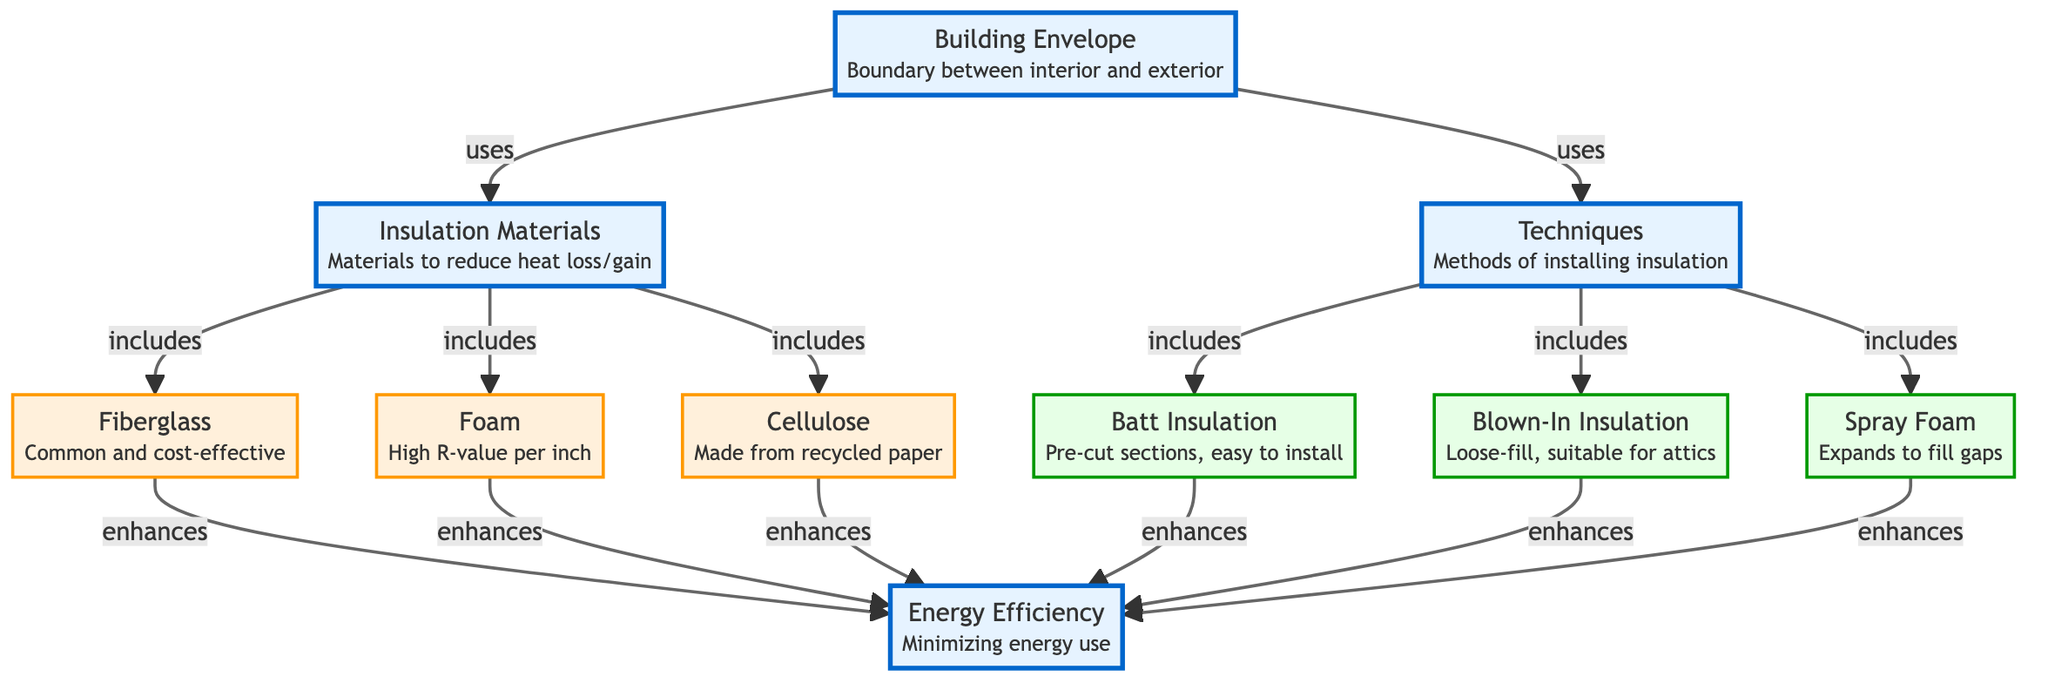What is the main purpose of the building envelope? The building envelope serves as the boundary between the interior and exterior of the building, helping to define the indoor climate.
Answer: Boundary between interior and exterior How many types of insulation materials are listed in the diagram? The diagram lists three types of insulation materials: Fiberglass, Foam, and Cellulose.
Answer: 3 What insulation technique is described as expanding to fill gaps? The technique described as expanding to fill gaps is Spray Foam, which is known for its ability to conform to spaces.
Answer: Spray Foam What enhances energy efficiency according to the diagram? Both insulation materials (Fiberglass, Foam, Cellulose) and installation techniques (Batts, Blown-In, Spray Foam) enhance energy efficiency, focusing on minimizing energy use in buildings.
Answer: Insulation materials and techniques Which insulation material is made from recycled paper? Cellulose is the insulation material made from recycled paper, emphasizing its environmentally friendly attributes.
Answer: Cellulose How are the insulation materials related to energy efficiency? The insulation materials (Fiberglass, Foam, Cellulose) enhance energy efficiency by reducing heat loss/gain, contributing to lower energy use in residential buildings.
Answer: Enhances energy efficiency What technique is characterized as suitable for attics? The Blown-In Insulation technique is characterized as loose-fill and is suitable for attics, providing a specific application for insulation.
Answer: Blown-In Insulation Which two nodes connect to the building envelope in the diagram? The building envelope connects to insulation materials and techniques, indicating its role in utilizing these components for energy efficiency.
Answer: Insulation materials and techniques What is the primary goal mentioned in the diagram related to energy use? The primary goal mentioned in the diagram is to minimize energy use, which aligns with achieving energy efficiency in residential buildings.
Answer: Minimizing energy use 